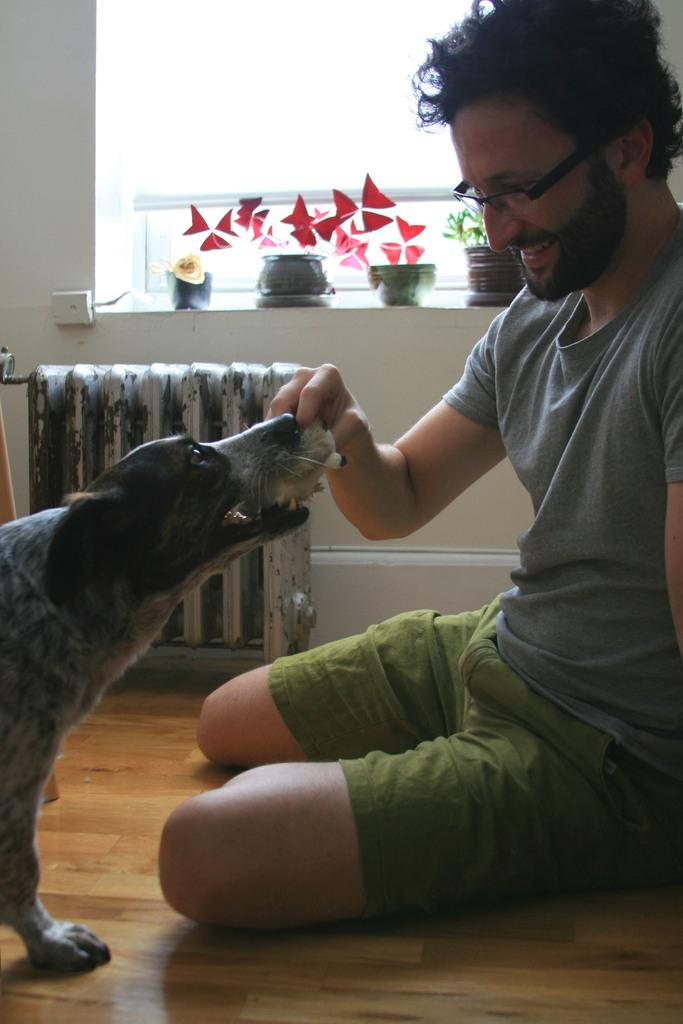What is the man in the image doing? The man is sitting in the middle of the image and smiling. What is the man holding in his hand? The man is holding something in his hand, but the specific object is not mentioned in the facts. What can be seen in the image besides the man? There is a dog, a wall, a window, and plants visible in the image. What is the purpose of the window in the image? The window allows natural light to enter the room and provides a view of the plants outside. How many friends can be seen crying in the image? There are no friends or crying individuals present in the image. 